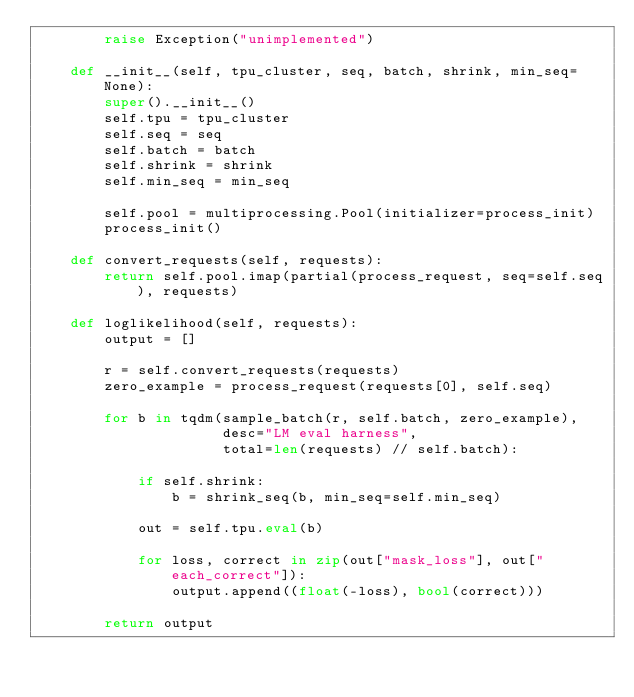Convert code to text. <code><loc_0><loc_0><loc_500><loc_500><_Python_>        raise Exception("unimplemented")

    def __init__(self, tpu_cluster, seq, batch, shrink, min_seq=None):
        super().__init__()
        self.tpu = tpu_cluster
        self.seq = seq
        self.batch = batch
        self.shrink = shrink
        self.min_seq = min_seq

        self.pool = multiprocessing.Pool(initializer=process_init)
        process_init()

    def convert_requests(self, requests):
        return self.pool.imap(partial(process_request, seq=self.seq), requests)

    def loglikelihood(self, requests):
        output = []

        r = self.convert_requests(requests)
        zero_example = process_request(requests[0], self.seq)

        for b in tqdm(sample_batch(r, self.batch, zero_example),
                      desc="LM eval harness",
                      total=len(requests) // self.batch):

            if self.shrink:
                b = shrink_seq(b, min_seq=self.min_seq)

            out = self.tpu.eval(b)

            for loss, correct in zip(out["mask_loss"], out["each_correct"]):
                output.append((float(-loss), bool(correct)))

        return output
</code> 